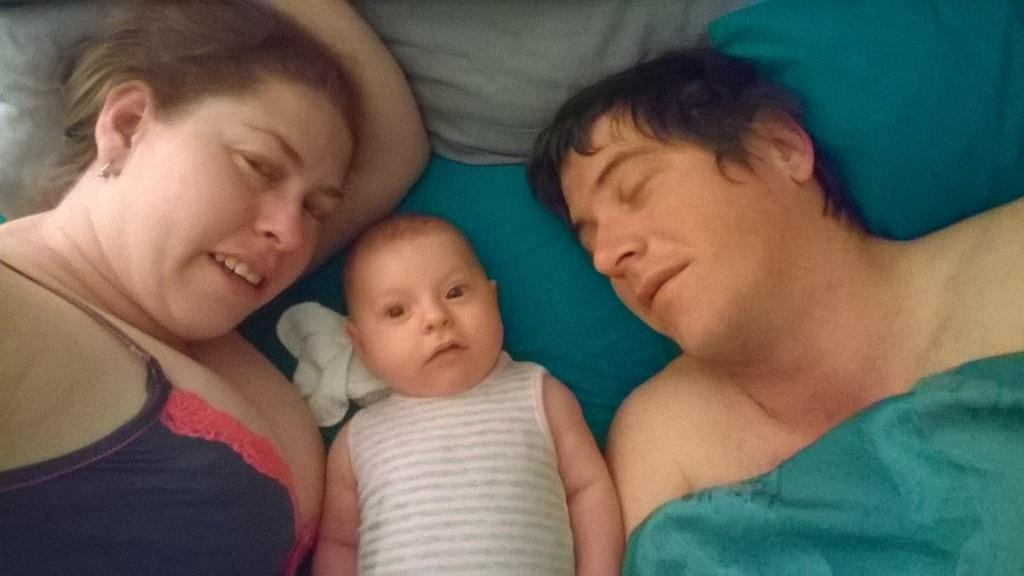Who are the people present in the image? There is a woman and a man in the image. What is the baby doing in the image? The baby is sleeping in the image. Where is the baby located in the image? The baby is on a bed in the image. What type of plane is the baby flying in the image? There is no plane present in the image; it features a woman, a man, and a baby sleeping on a bed. What time is it according to the clock in the image? There is no clock present in the image. 